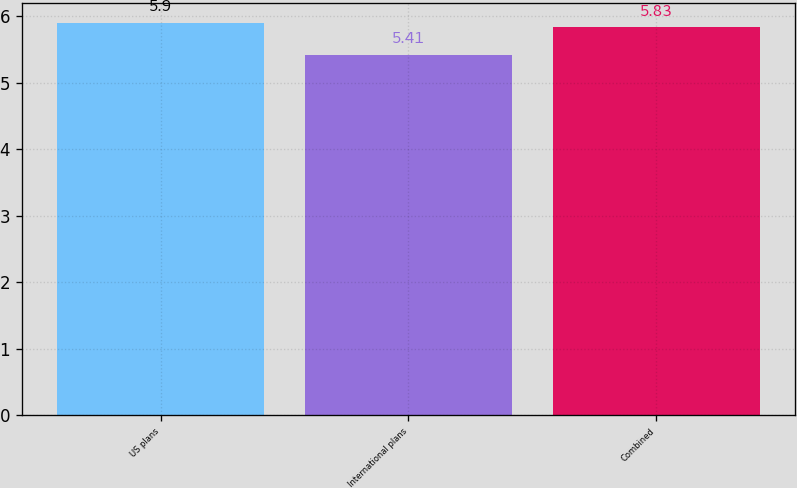<chart> <loc_0><loc_0><loc_500><loc_500><bar_chart><fcel>US plans<fcel>International plans<fcel>Combined<nl><fcel>5.9<fcel>5.41<fcel>5.83<nl></chart> 